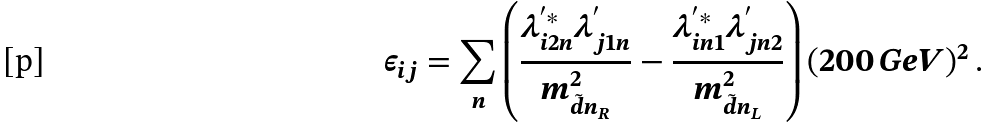Convert formula to latex. <formula><loc_0><loc_0><loc_500><loc_500>\epsilon _ { i j } = \sum _ { n } \left ( \frac { \lambda _ { i 2 n } ^ { ^ { \prime } * } \lambda _ { j 1 n } ^ { ^ { \prime } } } { m _ { \tilde { d } n _ { R } } ^ { 2 } } - \frac { \lambda _ { i n 1 } ^ { ^ { \prime } * } \lambda _ { j n 2 } ^ { ^ { \prime } } } { m _ { \tilde { d } n _ { L } } ^ { 2 } } \right ) ( 2 0 0 \, G e V ) ^ { 2 } \, .</formula> 